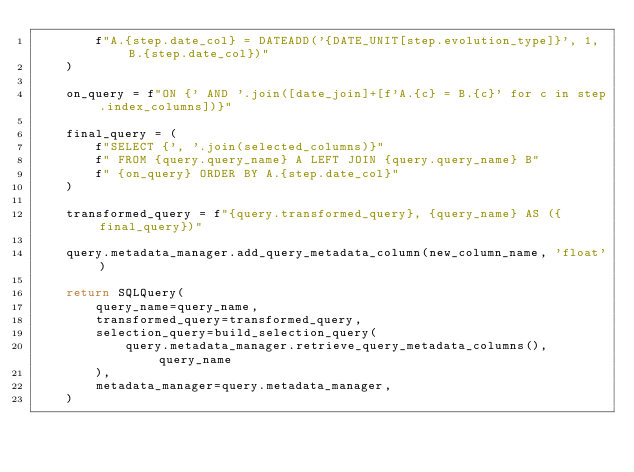Convert code to text. <code><loc_0><loc_0><loc_500><loc_500><_Python_>        f"A.{step.date_col} = DATEADD('{DATE_UNIT[step.evolution_type]}', 1, B.{step.date_col})"
    )

    on_query = f"ON {' AND '.join([date_join]+[f'A.{c} = B.{c}' for c in step.index_columns])}"

    final_query = (
        f"SELECT {', '.join(selected_columns)}"
        f" FROM {query.query_name} A LEFT JOIN {query.query_name} B"
        f" {on_query} ORDER BY A.{step.date_col}"
    )

    transformed_query = f"{query.transformed_query}, {query_name} AS ({final_query})"

    query.metadata_manager.add_query_metadata_column(new_column_name, 'float')

    return SQLQuery(
        query_name=query_name,
        transformed_query=transformed_query,
        selection_query=build_selection_query(
            query.metadata_manager.retrieve_query_metadata_columns(), query_name
        ),
        metadata_manager=query.metadata_manager,
    )
</code> 